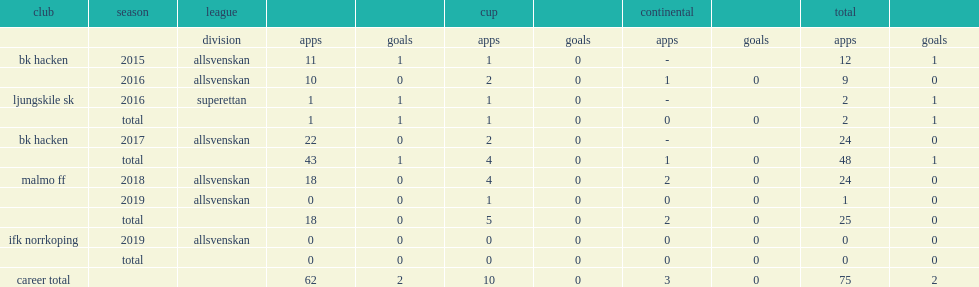Which club did egzon binaku play for in 2015? Bk hacken. 